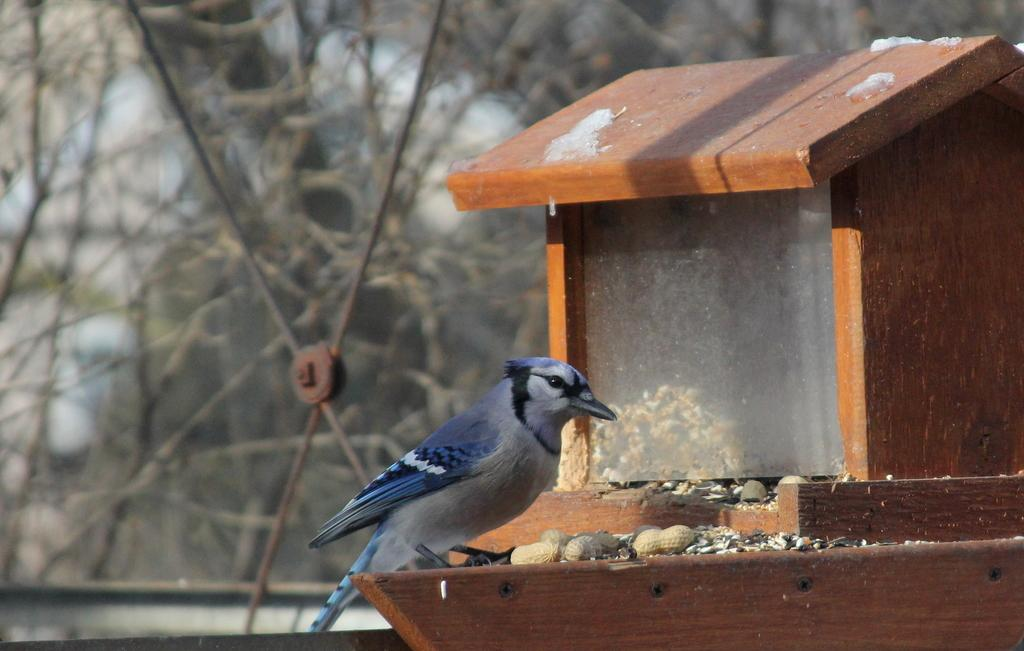What structure is present in the image? There is a birdhouse in the image. What type of animal can be seen in the image? There is a bird in the image, and it has a blue and black color. What type of food is visible in the image? There are groundnuts in the image, which can be considered food for the bird. What type of vegetation is present in the image? There are trees in the image. What type of mailbox is present in the image? There is no mailbox present in the image. What type of knife is being used by the bird in the image? There is no knife present in the image, and the bird is not using any tool. 